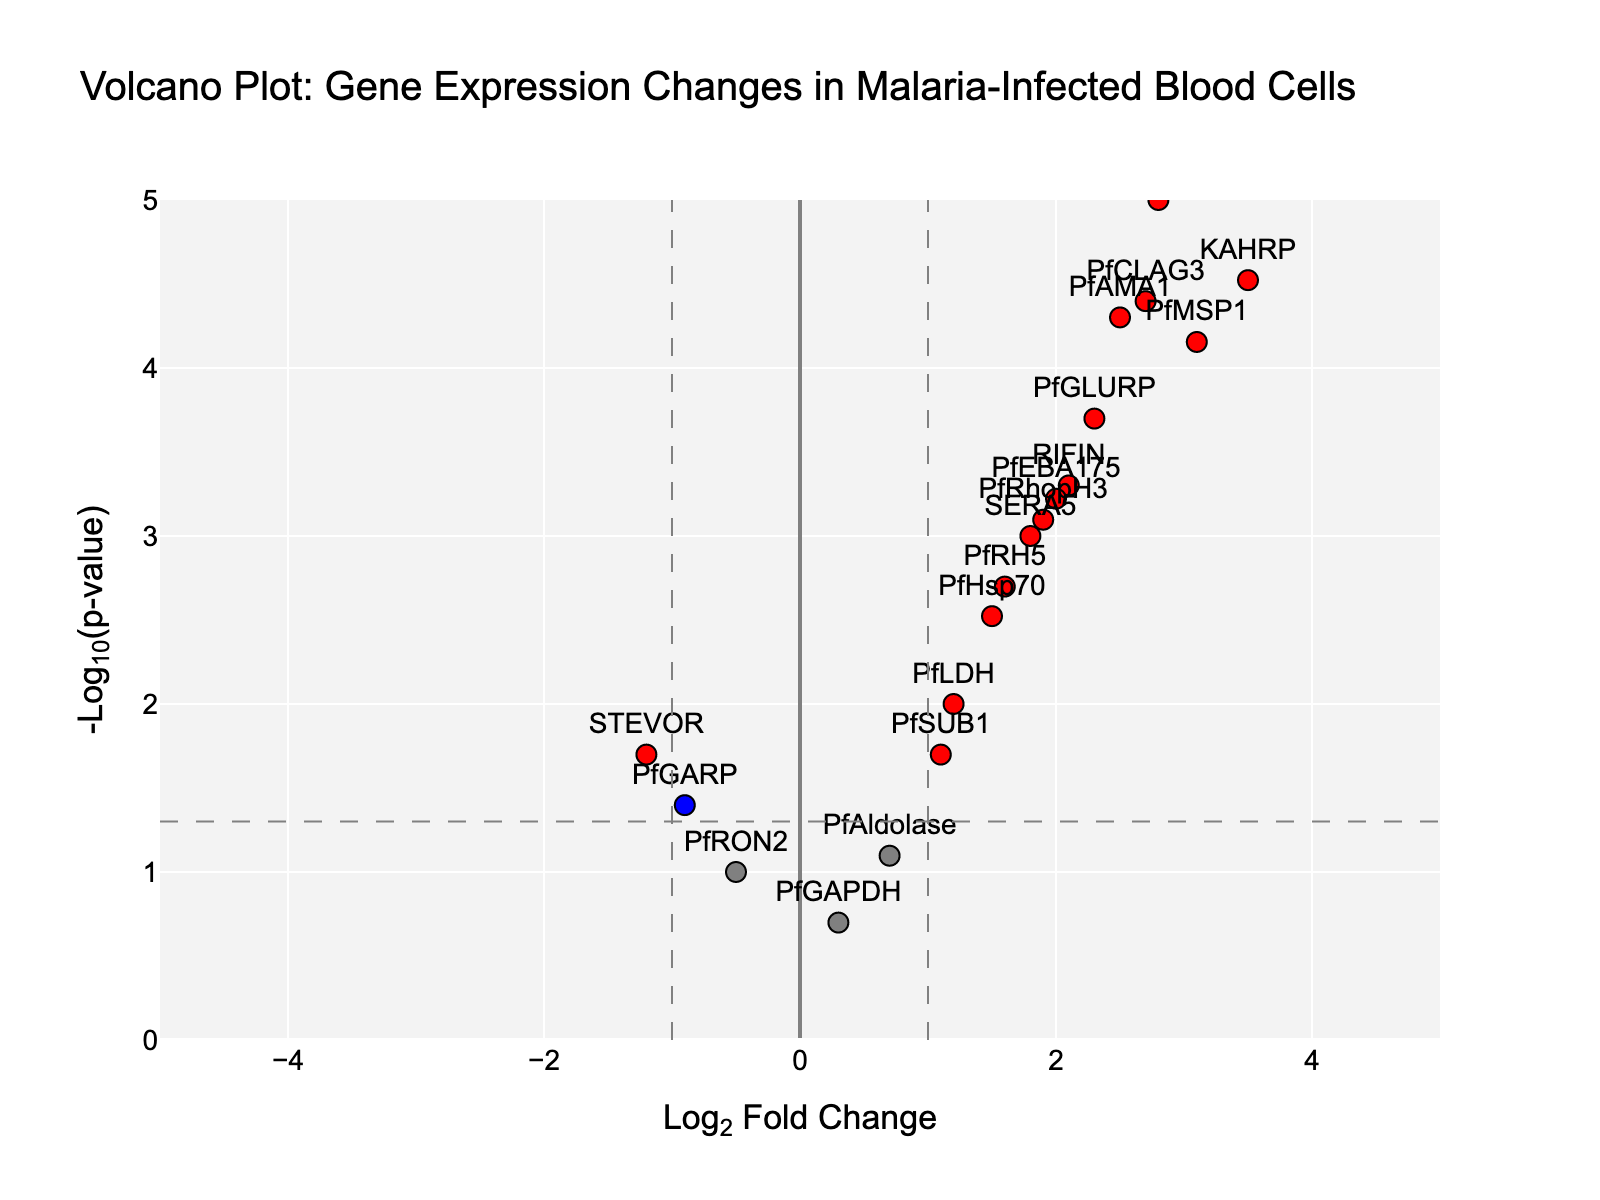How many genes are represented in the volcano plot? By counting the data points (genes) in the plot, the total number of genes can be determined.
Answer: 20 How is the significance of gene expression changes visually represented? The significance is represented by the y-axis (-Log10(p-value)). Higher points on the y-axis indicate more significant changes.
Answer: By y-axis height What does a red data point indicate in the plot? Red points signify genes with Log2 Fold Change greater than 1 or less than -1 and p-value less than 0.05.
Answer: Highly significant and large change How many genes show a Log2 Fold Change greater than 2? By identifying and counting the data points on the x-axis where the Log2 Fold Change is greater than 2.
Answer: 6 genes Which gene has the highest Log2 Fold Change and what is its value? By finding the data point positioned furthest to the right on the x-axis. The gene with the highest value is HRP2, with a Log2 Fold Change of 4.2.
Answer: HRP2, 4.2 Which gene has the smallest p-value and what is its value? By identifying the data point with the highest y-axis (highest -Log10(p-value)). The gene with the smallest p-value is HRP2.
Answer: HRP2, 0.000001 Compare the Log2 Fold Changes of PfEMP1 and KAHRP. Which gene has a greater expression change? By locating PfEMP1 and KAHRP on the x-axis and comparing their positions. KAHRP has a higher Log2 Fold Change than PfEMP1.
Answer: KAHRP What does a grey data point signify in the plot? Grey points indicate genes that do not meet the significance thresholds for either fold change or p-value.
Answer: Not significant Determine the number of genes with a p-value less than 0.01 but a Log2 Fold Change between -1 and 1. By selecting data points where the y-axis (-Log10(p)) indicates p-values less than 0.01 and identifying which of these have x-axis values (Log2 Fold Change) between -1 and 1.
Answer: 4 genes Identify a gene with a positive Log2 Fold Change but with one of the least significant p-values. By finding data points with positive x-values and then identifying those closest to the bottom on the y-axis. PfAldolase has a low significance with Log2 Fold Change of 0.7.
Answer: PfAldolase 